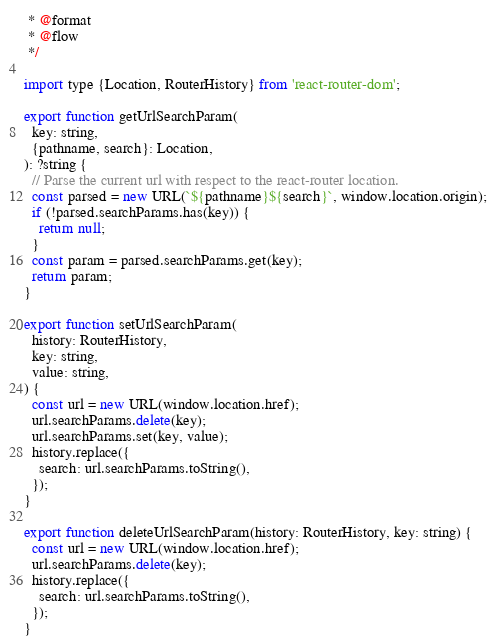Convert code to text. <code><loc_0><loc_0><loc_500><loc_500><_JavaScript_> * @format
 * @flow
 */

import type {Location, RouterHistory} from 'react-router-dom';

export function getUrlSearchParam(
  key: string,
  {pathname, search}: Location,
): ?string {
  // Parse the current url with respect to the react-router location.
  const parsed = new URL(`${pathname}${search}`, window.location.origin);
  if (!parsed.searchParams.has(key)) {
    return null;
  }
  const param = parsed.searchParams.get(key);
  return param;
}

export function setUrlSearchParam(
  history: RouterHistory,
  key: string,
  value: string,
) {
  const url = new URL(window.location.href);
  url.searchParams.delete(key);
  url.searchParams.set(key, value);
  history.replace({
    search: url.searchParams.toString(),
  });
}

export function deleteUrlSearchParam(history: RouterHistory, key: string) {
  const url = new URL(window.location.href);
  url.searchParams.delete(key);
  history.replace({
    search: url.searchParams.toString(),
  });
}
</code> 